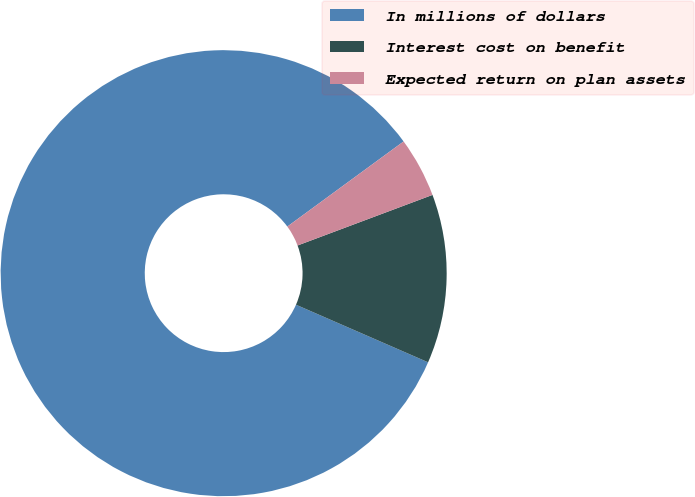<chart> <loc_0><loc_0><loc_500><loc_500><pie_chart><fcel>In millions of dollars<fcel>Interest cost on benefit<fcel>Expected return on plan assets<nl><fcel>83.4%<fcel>12.25%<fcel>4.35%<nl></chart> 